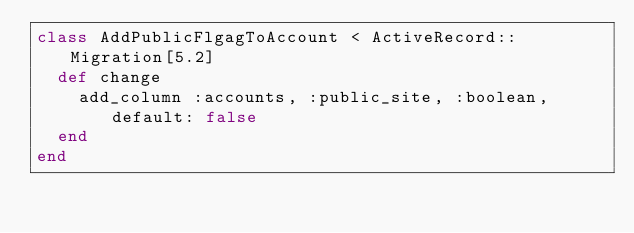Convert code to text. <code><loc_0><loc_0><loc_500><loc_500><_Ruby_>class AddPublicFlgagToAccount < ActiveRecord::Migration[5.2]
  def change
    add_column :accounts, :public_site, :boolean, default: false
  end
end
</code> 